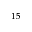Convert formula to latex. <formula><loc_0><loc_0><loc_500><loc_500>^ { 1 5 }</formula> 